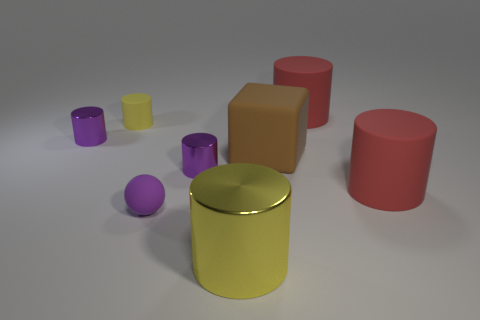There is a rubber object that is the same size as the purple ball; what color is it? The rubber object that shares the same size attributes as the purple ball in the image is a vibrant yellow. 